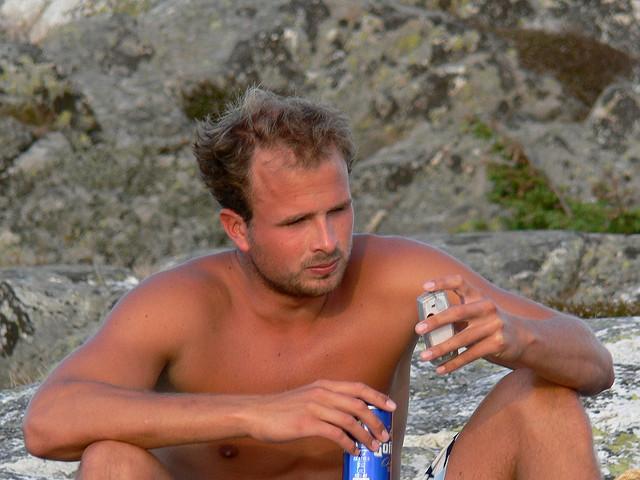Has it been more than one month or less than one week since this man has shaved?
Concise answer only. Less than one week. What is the man holding in his right hand?
Answer briefly. Drink. Is the man outside?
Short answer required. Yes. 